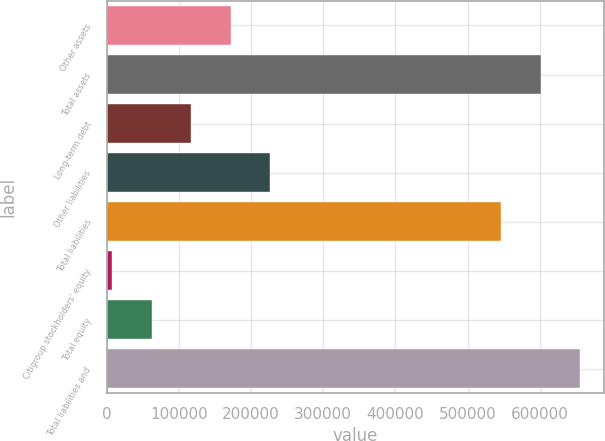Convert chart. <chart><loc_0><loc_0><loc_500><loc_500><bar_chart><fcel>Other assets<fcel>Total assets<fcel>Long-term debt<fcel>Other liabilities<fcel>Total liabilities<fcel>Citigroup stockholders' equity<fcel>Total equity<fcel>Total liabilities and<nl><fcel>171835<fcel>600918<fcel>117163<fcel>226507<fcel>546246<fcel>7819<fcel>62491.1<fcel>655590<nl></chart> 